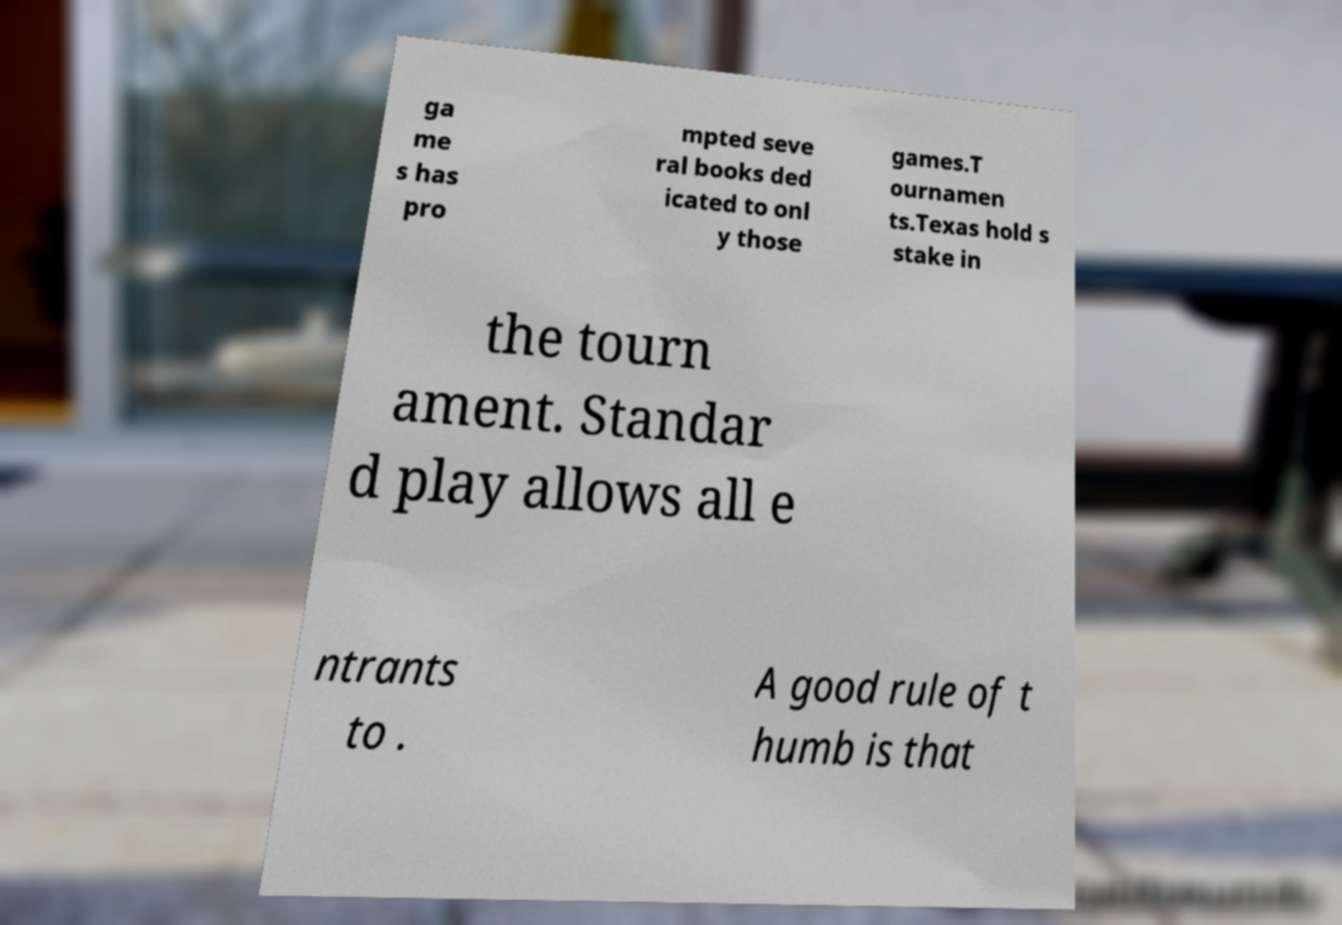There's text embedded in this image that I need extracted. Can you transcribe it verbatim? ga me s has pro mpted seve ral books ded icated to onl y those games.T ournamen ts.Texas hold s stake in the tourn ament. Standar d play allows all e ntrants to . A good rule of t humb is that 